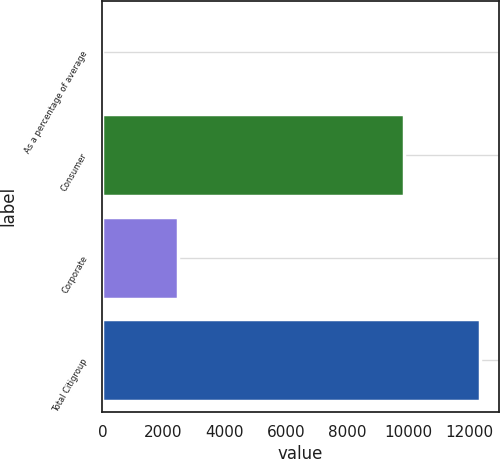Convert chart to OTSL. <chart><loc_0><loc_0><loc_500><loc_500><bar_chart><fcel>As a percentage of average<fcel>Consumer<fcel>Corporate<fcel>Total Citigroup<nl><fcel>0.12<fcel>9869<fcel>2486<fcel>12355<nl></chart> 